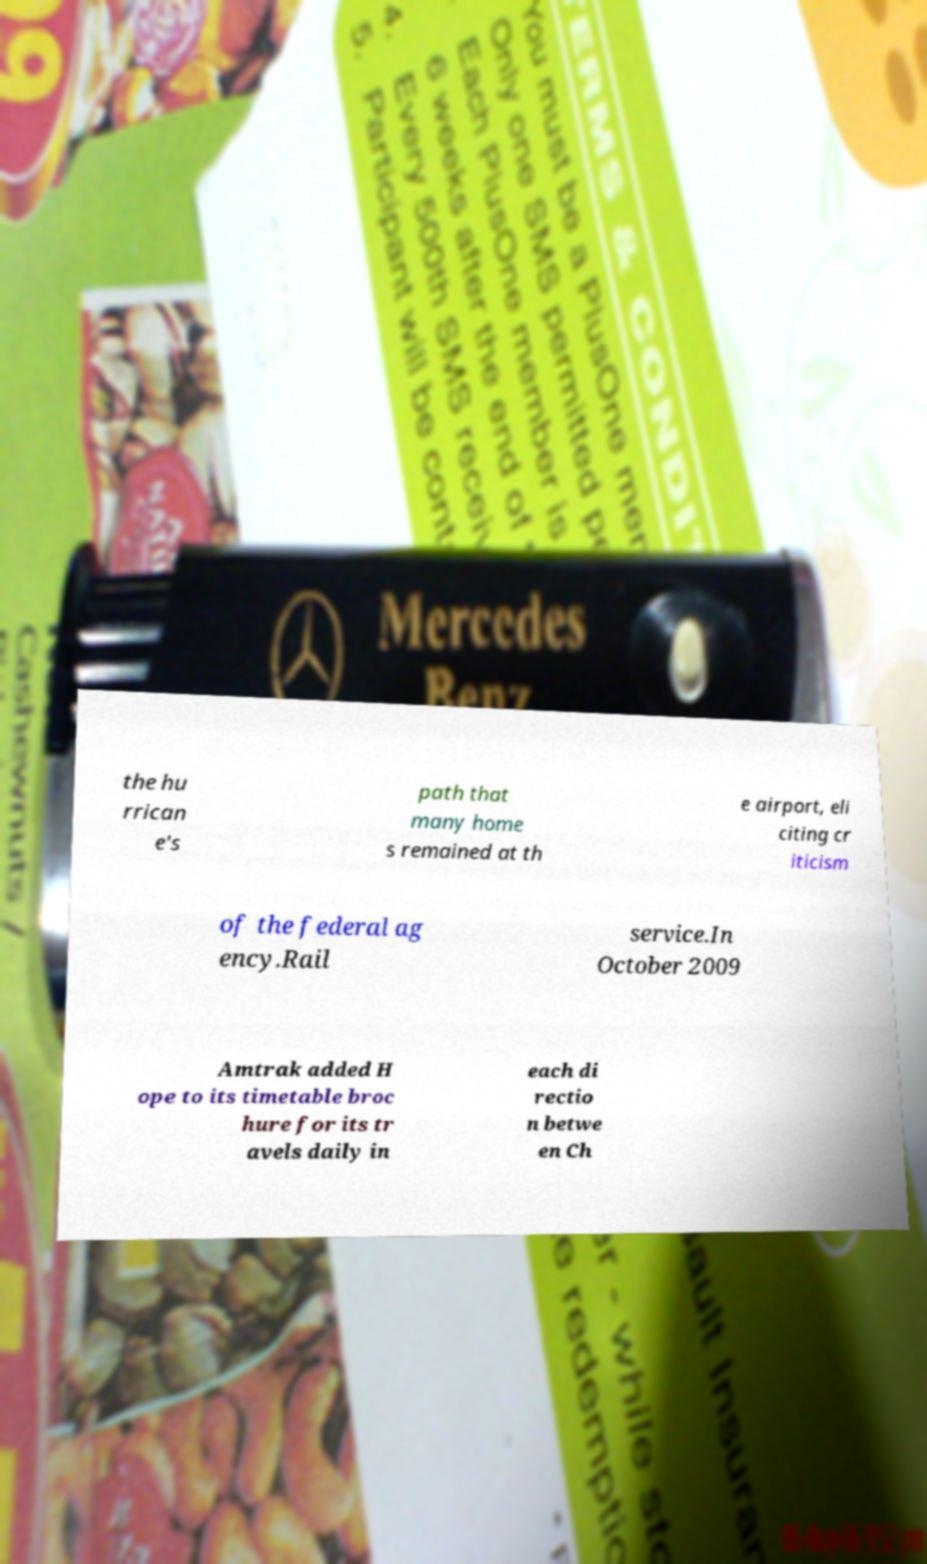For documentation purposes, I need the text within this image transcribed. Could you provide that? the hu rrican e's path that many home s remained at th e airport, eli citing cr iticism of the federal ag ency.Rail service.In October 2009 Amtrak added H ope to its timetable broc hure for its tr avels daily in each di rectio n betwe en Ch 